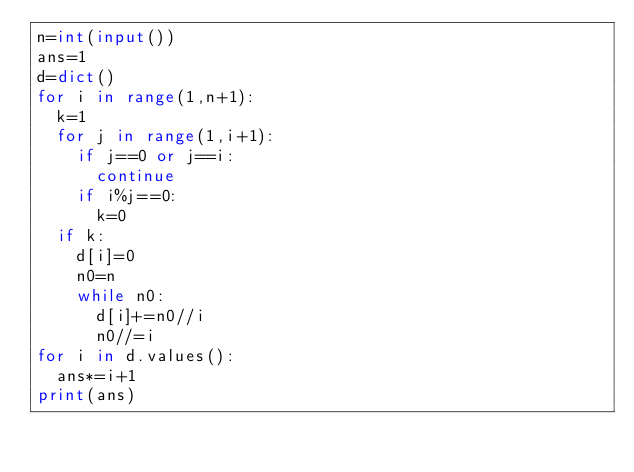<code> <loc_0><loc_0><loc_500><loc_500><_Python_>n=int(input())
ans=1
d=dict()
for i in range(1,n+1):
  k=1
  for j in range(1,i+1):
    if j==0 or j==i:
      continue
    if i%j==0:
      k=0
  if k:
    d[i]=0
    n0=n
    while n0:
      d[i]+=n0//i
      n0//=i
for i in d.values():
  ans*=i+1
print(ans)</code> 